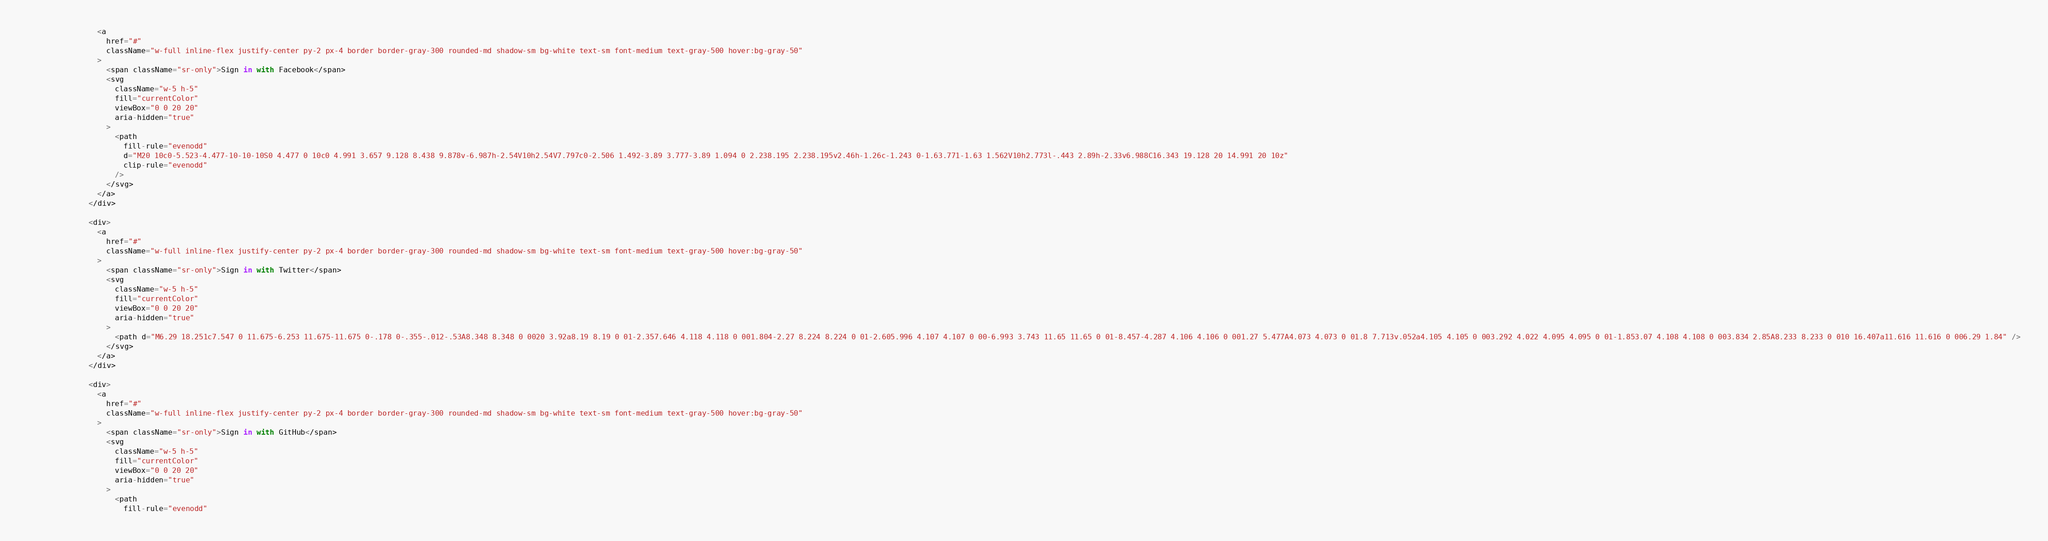<code> <loc_0><loc_0><loc_500><loc_500><_TypeScript_>                <a
                  href="#"
                  className="w-full inline-flex justify-center py-2 px-4 border border-gray-300 rounded-md shadow-sm bg-white text-sm font-medium text-gray-500 hover:bg-gray-50"
                >
                  <span className="sr-only">Sign in with Facebook</span>
                  <svg
                    className="w-5 h-5"
                    fill="currentColor"
                    viewBox="0 0 20 20"
                    aria-hidden="true"
                  >
                    <path
                      fill-rule="evenodd"
                      d="M20 10c0-5.523-4.477-10-10-10S0 4.477 0 10c0 4.991 3.657 9.128 8.438 9.878v-6.987h-2.54V10h2.54V7.797c0-2.506 1.492-3.89 3.777-3.89 1.094 0 2.238.195 2.238.195v2.46h-1.26c-1.243 0-1.63.771-1.63 1.562V10h2.773l-.443 2.89h-2.33v6.988C16.343 19.128 20 14.991 20 10z"
                      clip-rule="evenodd"
                    />
                  </svg>
                </a>
              </div>

              <div>
                <a
                  href="#"
                  className="w-full inline-flex justify-center py-2 px-4 border border-gray-300 rounded-md shadow-sm bg-white text-sm font-medium text-gray-500 hover:bg-gray-50"
                >
                  <span className="sr-only">Sign in with Twitter</span>
                  <svg
                    className="w-5 h-5"
                    fill="currentColor"
                    viewBox="0 0 20 20"
                    aria-hidden="true"
                  >
                    <path d="M6.29 18.251c7.547 0 11.675-6.253 11.675-11.675 0-.178 0-.355-.012-.53A8.348 8.348 0 0020 3.92a8.19 8.19 0 01-2.357.646 4.118 4.118 0 001.804-2.27 8.224 8.224 0 01-2.605.996 4.107 4.107 0 00-6.993 3.743 11.65 11.65 0 01-8.457-4.287 4.106 4.106 0 001.27 5.477A4.073 4.073 0 01.8 7.713v.052a4.105 4.105 0 003.292 4.022 4.095 4.095 0 01-1.853.07 4.108 4.108 0 003.834 2.85A8.233 8.233 0 010 16.407a11.616 11.616 0 006.29 1.84" />
                  </svg>
                </a>
              </div>

              <div>
                <a
                  href="#"
                  className="w-full inline-flex justify-center py-2 px-4 border border-gray-300 rounded-md shadow-sm bg-white text-sm font-medium text-gray-500 hover:bg-gray-50"
                >
                  <span className="sr-only">Sign in with GitHub</span>
                  <svg
                    className="w-5 h-5"
                    fill="currentColor"
                    viewBox="0 0 20 20"
                    aria-hidden="true"
                  >
                    <path
                      fill-rule="evenodd"</code> 